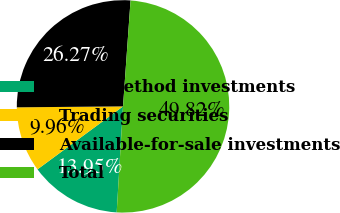Convert chart to OTSL. <chart><loc_0><loc_0><loc_500><loc_500><pie_chart><fcel>Cost method investments<fcel>Trading securities<fcel>Available-for-sale investments<fcel>Total<nl><fcel>13.95%<fcel>9.96%<fcel>26.27%<fcel>49.82%<nl></chart> 